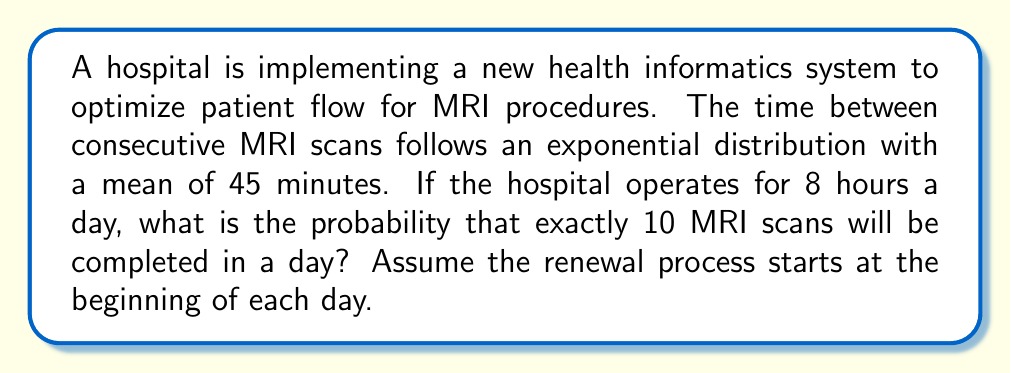Solve this math problem. Let's approach this step-by-step:

1) This scenario can be modeled as a Poisson process, which is a special case of a renewal process where inter-arrival times are exponentially distributed.

2) The rate parameter $\lambda$ of the Poisson process is the inverse of the mean inter-arrival time:

   $\lambda = \frac{1}{45 \text{ minutes}} = \frac{1}{45} \text{ scans per minute}$

3) For an 8-hour day, we need to calculate $\lambda$ in terms of scans per day:

   $\lambda_{\text{day}} = \frac{1}{45} \times 60 \text{ minutes/hour} \times 8 \text{ hours/day} = 10.67 \text{ scans/day}$

4) The probability of exactly $k$ events in a Poisson process over an interval $t$ is given by the Poisson probability mass function:

   $P(X = k) = \frac{e^{-\lambda t}(\lambda t)^k}{k!}$

5) In our case, $k = 10$, $\lambda t = 10.67$, so:

   $P(X = 10) = \frac{e^{-10.67}(10.67)^{10}}{10!}$

6) Calculating this:

   $P(X = 10) = \frac{e^{-10.67}(10.67)^{10}}{3,628,800} \approx 0.1255$

Therefore, the probability of exactly 10 MRI scans being completed in a day is approximately 0.1255 or 12.55%.
Answer: 0.1255 